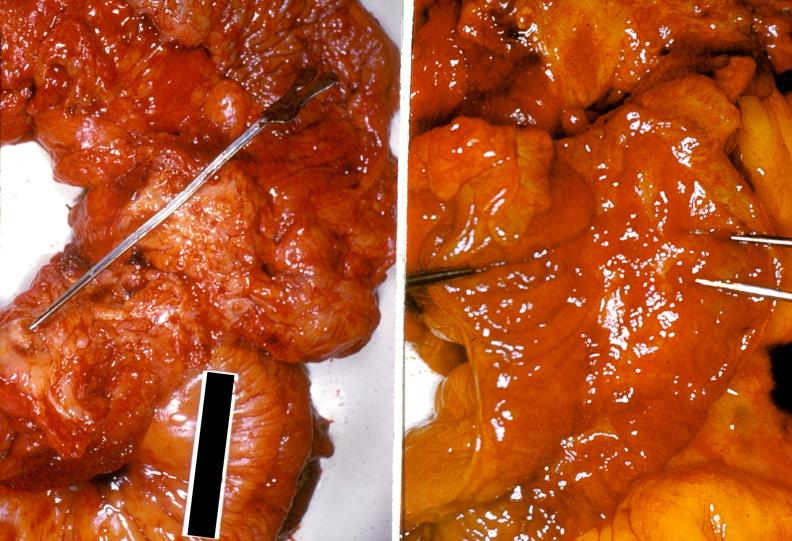what does this image show?
Answer the question using a single word or phrase. Ileum 